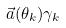<formula> <loc_0><loc_0><loc_500><loc_500>\vec { a } ( \theta _ { k } ) \gamma _ { k }</formula> 